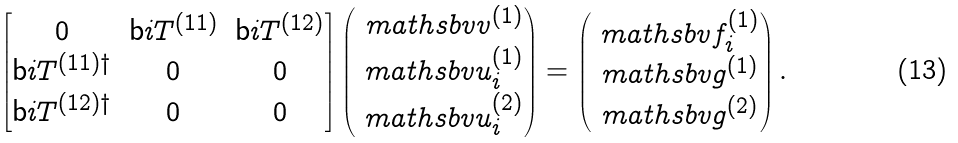<formula> <loc_0><loc_0><loc_500><loc_500>\begin{bmatrix} 0 & \mathsf b i { T } ^ { ( 1 1 ) } & \mathsf b i { T } ^ { ( 1 2 ) } \\ \mathsf b i { T } ^ { ( 1 1 ) \dagger } & 0 & 0 \\ \mathsf b i { T } ^ { ( 1 2 ) \dagger } & 0 & 0 \\ \end{bmatrix} \begin{pmatrix} \ m a t h s b v { v } ^ { ( 1 ) } \\ \ m a t h s b v { u } _ { i } ^ { ( 1 ) } \\ \ m a t h s b v { u } _ { i } ^ { ( 2 ) } \end{pmatrix} = \begin{pmatrix} \ m a t h s b v { f } _ { i } ^ { ( 1 ) } \\ \ m a t h s b v { g } ^ { ( 1 ) } \\ \ m a t h s b v { g } ^ { ( 2 ) } \end{pmatrix} .</formula> 